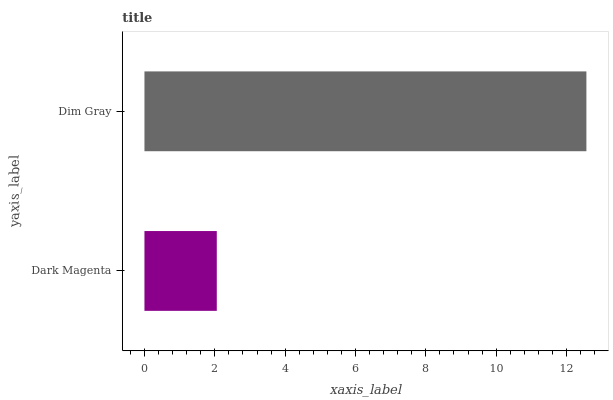Is Dark Magenta the minimum?
Answer yes or no. Yes. Is Dim Gray the maximum?
Answer yes or no. Yes. Is Dim Gray the minimum?
Answer yes or no. No. Is Dim Gray greater than Dark Magenta?
Answer yes or no. Yes. Is Dark Magenta less than Dim Gray?
Answer yes or no. Yes. Is Dark Magenta greater than Dim Gray?
Answer yes or no. No. Is Dim Gray less than Dark Magenta?
Answer yes or no. No. Is Dim Gray the high median?
Answer yes or no. Yes. Is Dark Magenta the low median?
Answer yes or no. Yes. Is Dark Magenta the high median?
Answer yes or no. No. Is Dim Gray the low median?
Answer yes or no. No. 